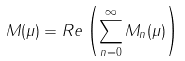<formula> <loc_0><loc_0><loc_500><loc_500>M ( \mu ) = R e \left ( \sum _ { n = 0 } ^ { \infty } M _ { n } ( \mu ) \right )</formula> 